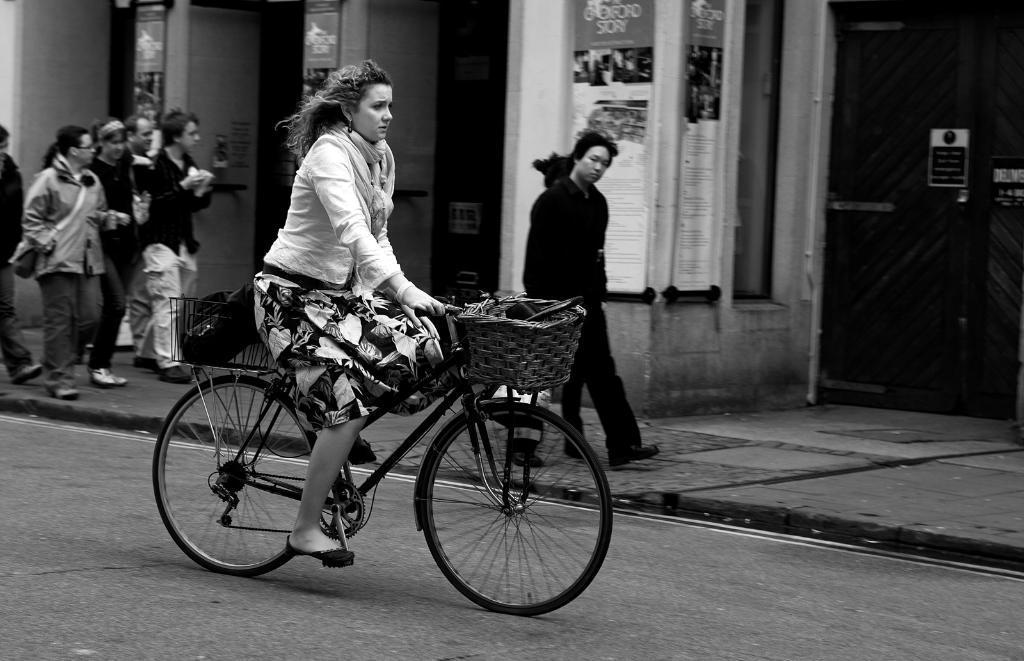Can you describe this image briefly? A lady is riding a bicycle with a wooden compartment in front of the cycle. In the background there is a pedestrian walk way and people are walking around it. There are few shop in the background. 